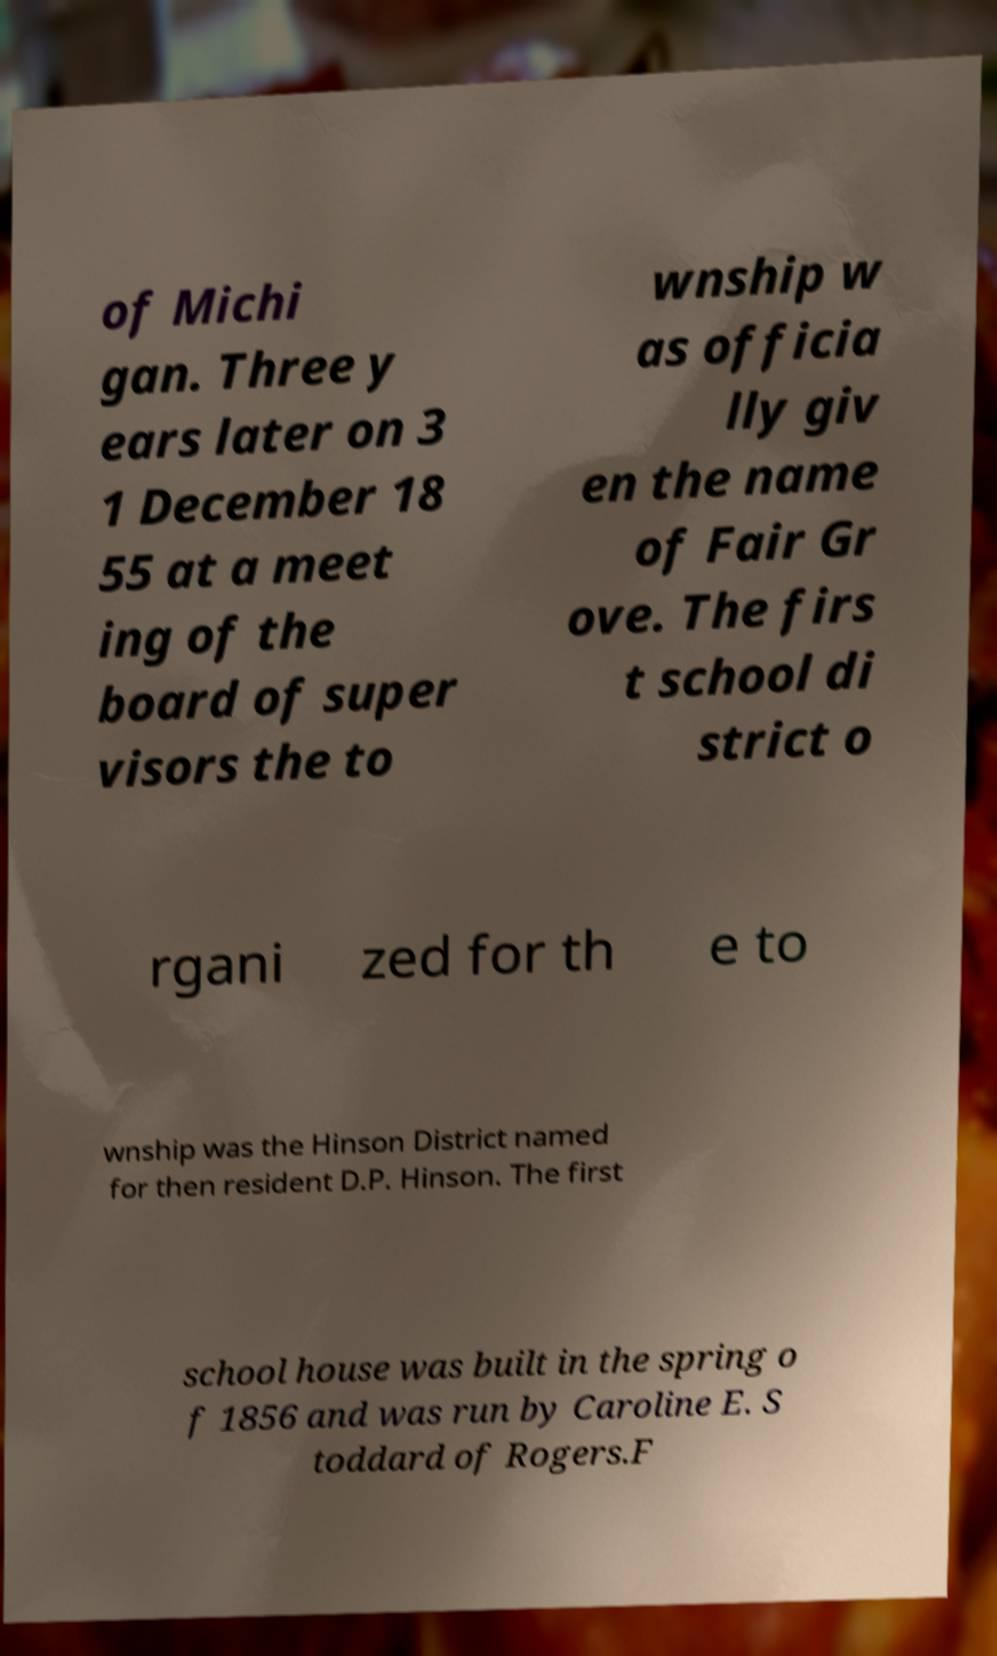Please read and relay the text visible in this image. What does it say? of Michi gan. Three y ears later on 3 1 December 18 55 at a meet ing of the board of super visors the to wnship w as officia lly giv en the name of Fair Gr ove. The firs t school di strict o rgani zed for th e to wnship was the Hinson District named for then resident D.P. Hinson. The first school house was built in the spring o f 1856 and was run by Caroline E. S toddard of Rogers.F 